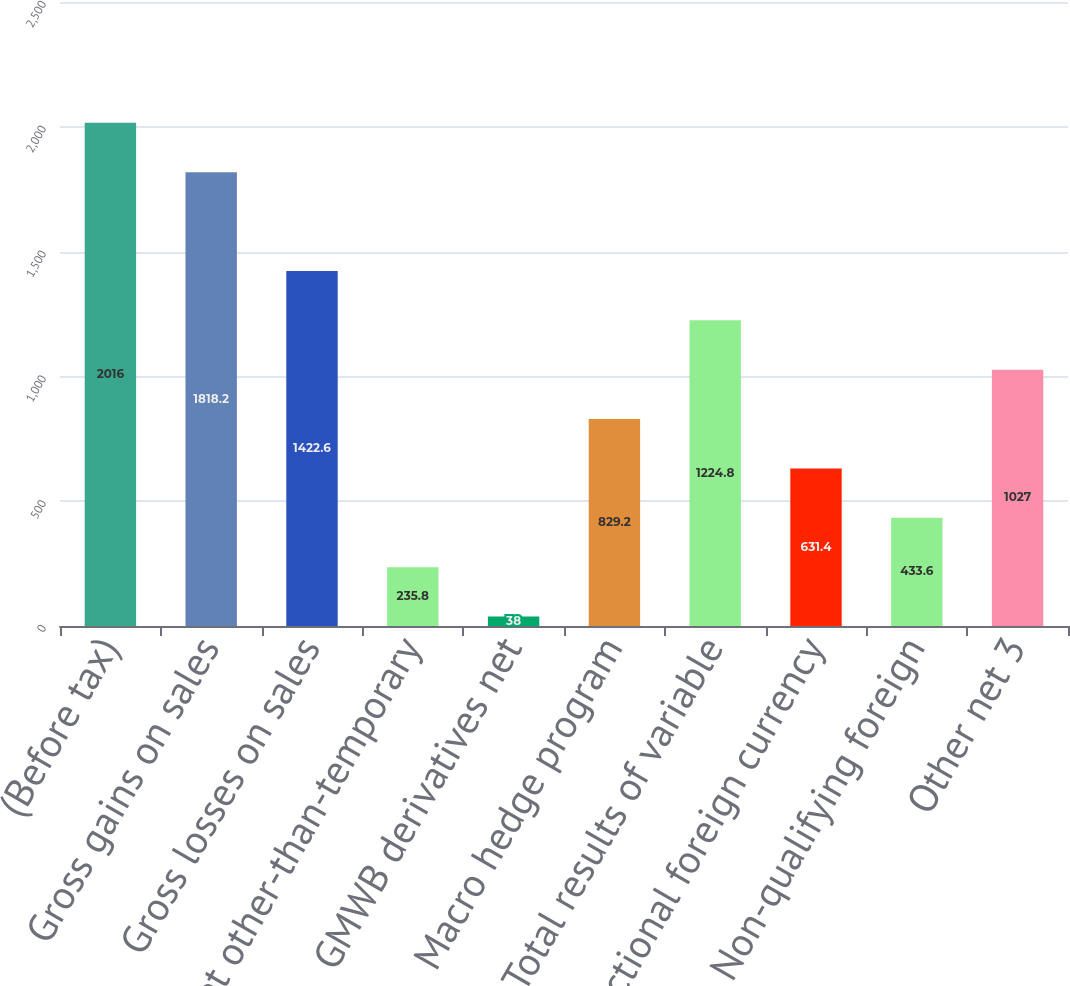<chart> <loc_0><loc_0><loc_500><loc_500><bar_chart><fcel>(Before tax)<fcel>Gross gains on sales<fcel>Gross losses on sales<fcel>Net other-than-temporary<fcel>GMWB derivatives net<fcel>Macro hedge program<fcel>Total results of variable<fcel>Transactional foreign currency<fcel>Non-qualifying foreign<fcel>Other net 3<nl><fcel>2016<fcel>1818.2<fcel>1422.6<fcel>235.8<fcel>38<fcel>829.2<fcel>1224.8<fcel>631.4<fcel>433.6<fcel>1027<nl></chart> 